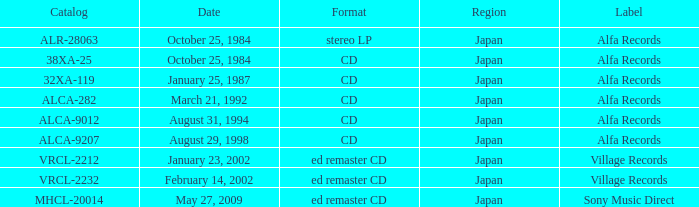What is the region of the Alfa Records release with catalog ALCA-282? Japan. 